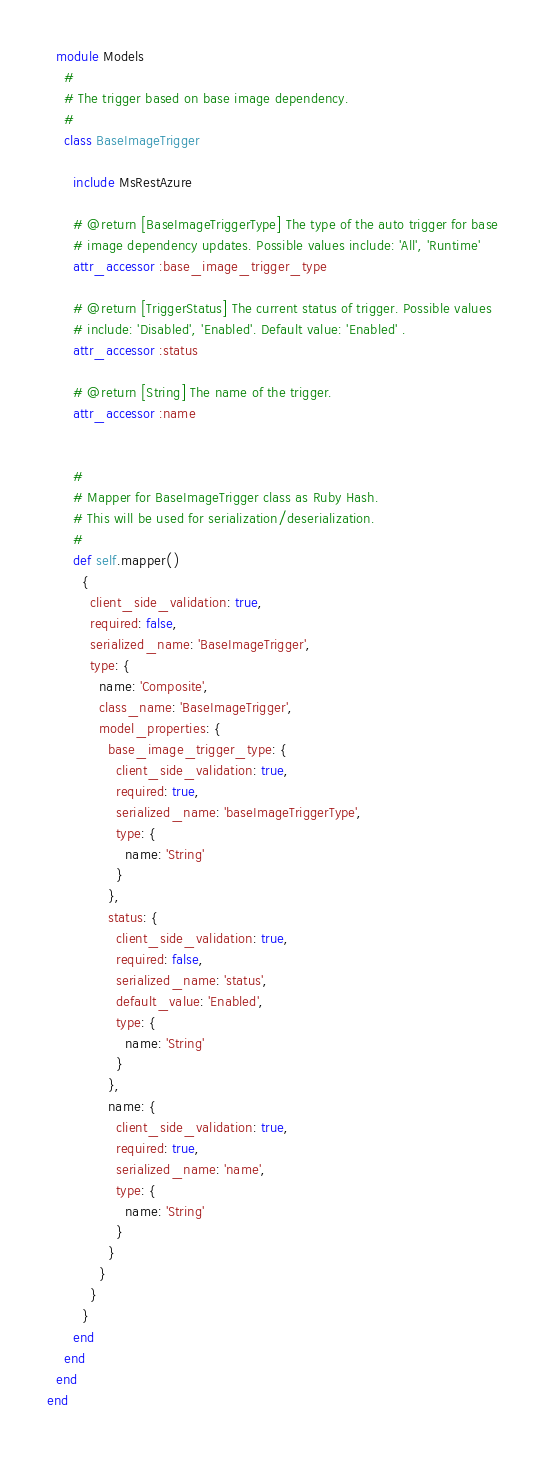Convert code to text. <code><loc_0><loc_0><loc_500><loc_500><_Ruby_>  module Models
    #
    # The trigger based on base image dependency.
    #
    class BaseImageTrigger

      include MsRestAzure

      # @return [BaseImageTriggerType] The type of the auto trigger for base
      # image dependency updates. Possible values include: 'All', 'Runtime'
      attr_accessor :base_image_trigger_type

      # @return [TriggerStatus] The current status of trigger. Possible values
      # include: 'Disabled', 'Enabled'. Default value: 'Enabled' .
      attr_accessor :status

      # @return [String] The name of the trigger.
      attr_accessor :name


      #
      # Mapper for BaseImageTrigger class as Ruby Hash.
      # This will be used for serialization/deserialization.
      #
      def self.mapper()
        {
          client_side_validation: true,
          required: false,
          serialized_name: 'BaseImageTrigger',
          type: {
            name: 'Composite',
            class_name: 'BaseImageTrigger',
            model_properties: {
              base_image_trigger_type: {
                client_side_validation: true,
                required: true,
                serialized_name: 'baseImageTriggerType',
                type: {
                  name: 'String'
                }
              },
              status: {
                client_side_validation: true,
                required: false,
                serialized_name: 'status',
                default_value: 'Enabled',
                type: {
                  name: 'String'
                }
              },
              name: {
                client_side_validation: true,
                required: true,
                serialized_name: 'name',
                type: {
                  name: 'String'
                }
              }
            }
          }
        }
      end
    end
  end
end
</code> 